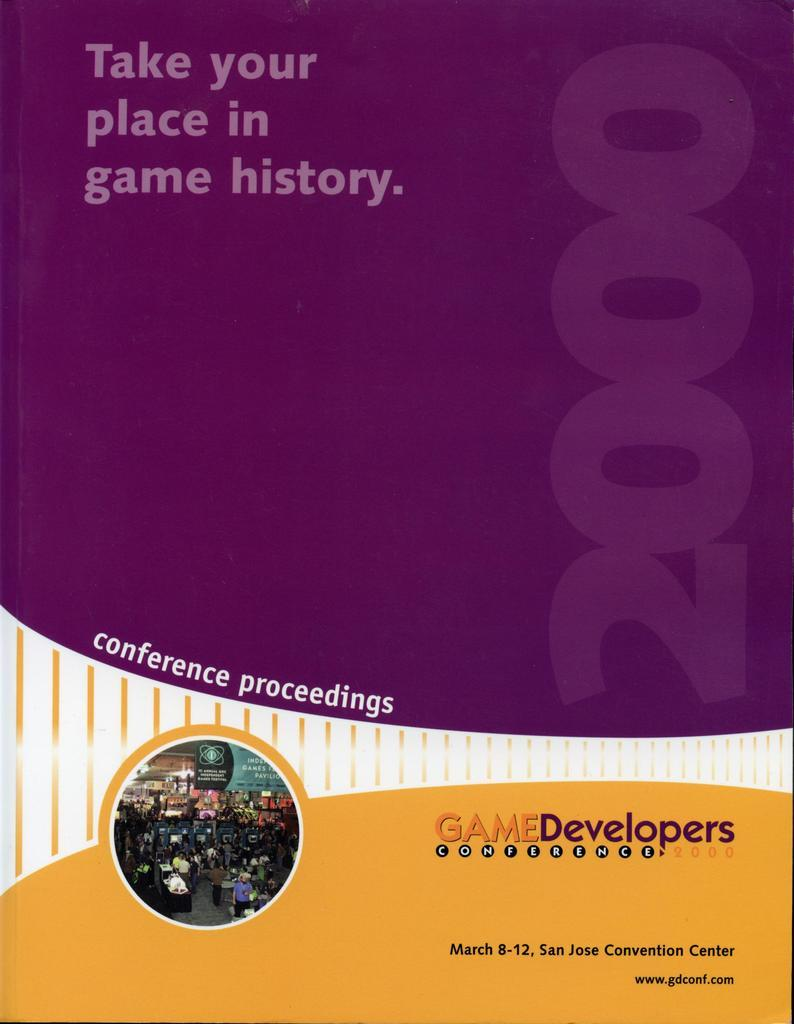<image>
Give a short and clear explanation of the subsequent image. A book of conference proceedings for Game Developers. 